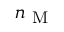<formula> <loc_0><loc_0><loc_500><loc_500>n _ { M }</formula> 